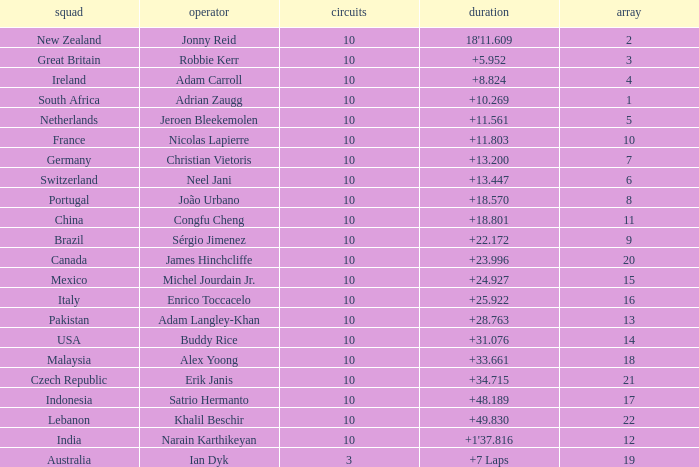What team had 10 Labs and the Driver was Alex Yoong? Malaysia. 